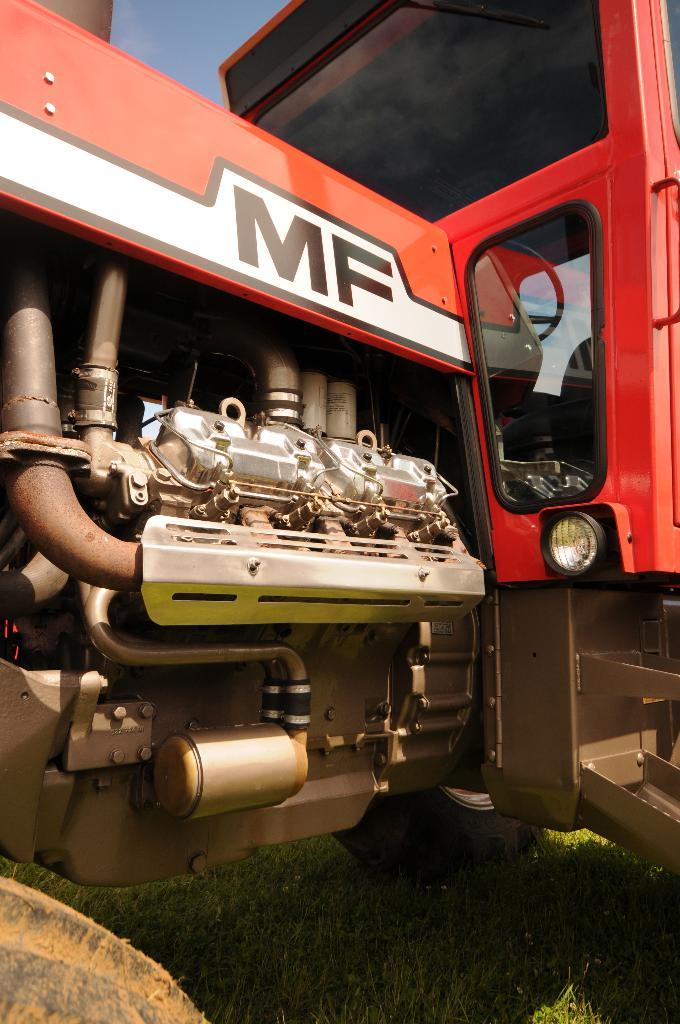What is the main subject of the image? The main subject of the image is an engine of a vehicle. Where is the engine located in the image? The engine is placed on the ground. What is the ground covered with? The ground is covered with grass. What type of soap is being used to clean the engine in the image? There is no soap present in the image, and the engine is not being cleaned. 